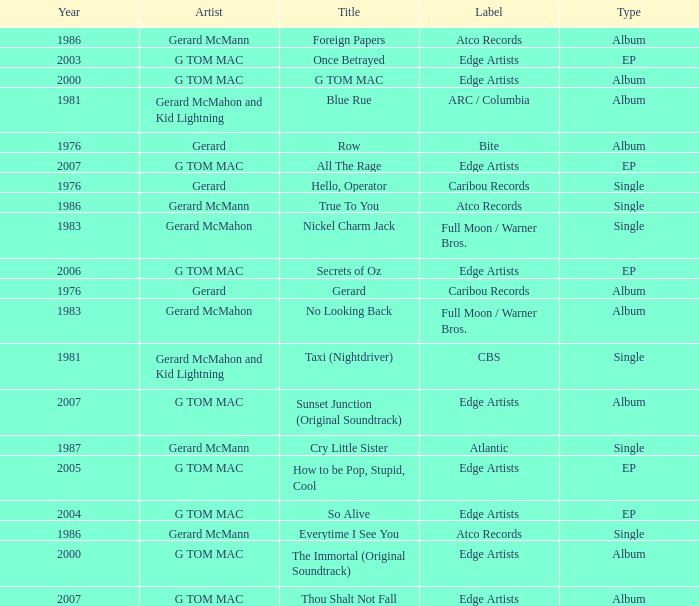Would you be able to parse every entry in this table? {'header': ['Year', 'Artist', 'Title', 'Label', 'Type'], 'rows': [['1986', 'Gerard McMann', 'Foreign Papers', 'Atco Records', 'Album'], ['2003', 'G TOM MAC', 'Once Betrayed', 'Edge Artists', 'EP'], ['2000', 'G TOM MAC', 'G TOM MAC', 'Edge Artists', 'Album'], ['1981', 'Gerard McMahon and Kid Lightning', 'Blue Rue', 'ARC / Columbia', 'Album'], ['1976', 'Gerard', 'Row', 'Bite', 'Album'], ['2007', 'G TOM MAC', 'All The Rage', 'Edge Artists', 'EP'], ['1976', 'Gerard', 'Hello, Operator', 'Caribou Records', 'Single'], ['1986', 'Gerard McMann', 'True To You', 'Atco Records', 'Single'], ['1983', 'Gerard McMahon', 'Nickel Charm Jack', 'Full Moon / Warner Bros.', 'Single'], ['2006', 'G TOM MAC', 'Secrets of Oz', 'Edge Artists', 'EP'], ['1976', 'Gerard', 'Gerard', 'Caribou Records', 'Album'], ['1983', 'Gerard McMahon', 'No Looking Back', 'Full Moon / Warner Bros.', 'Album'], ['1981', 'Gerard McMahon and Kid Lightning', 'Taxi (Nightdriver)', 'CBS', 'Single'], ['2007', 'G TOM MAC', 'Sunset Junction (Original Soundtrack)', 'Edge Artists', 'Album'], ['1987', 'Gerard McMann', 'Cry Little Sister', 'Atlantic', 'Single'], ['2005', 'G TOM MAC', 'How to be Pop, Stupid, Cool', 'Edge Artists', 'EP'], ['2004', 'G TOM MAC', 'So Alive', 'Edge Artists', 'EP'], ['1986', 'Gerard McMann', 'Everytime I See You', 'Atco Records', 'Single'], ['2000', 'G TOM MAC', 'The Immortal (Original Soundtrack)', 'Edge Artists', 'Album'], ['2007', 'G TOM MAC', 'Thou Shalt Not Fall', 'Edge Artists', 'Album']]} Name the Year which has a Label of atco records and a Type of album? Question 2 1986.0. 